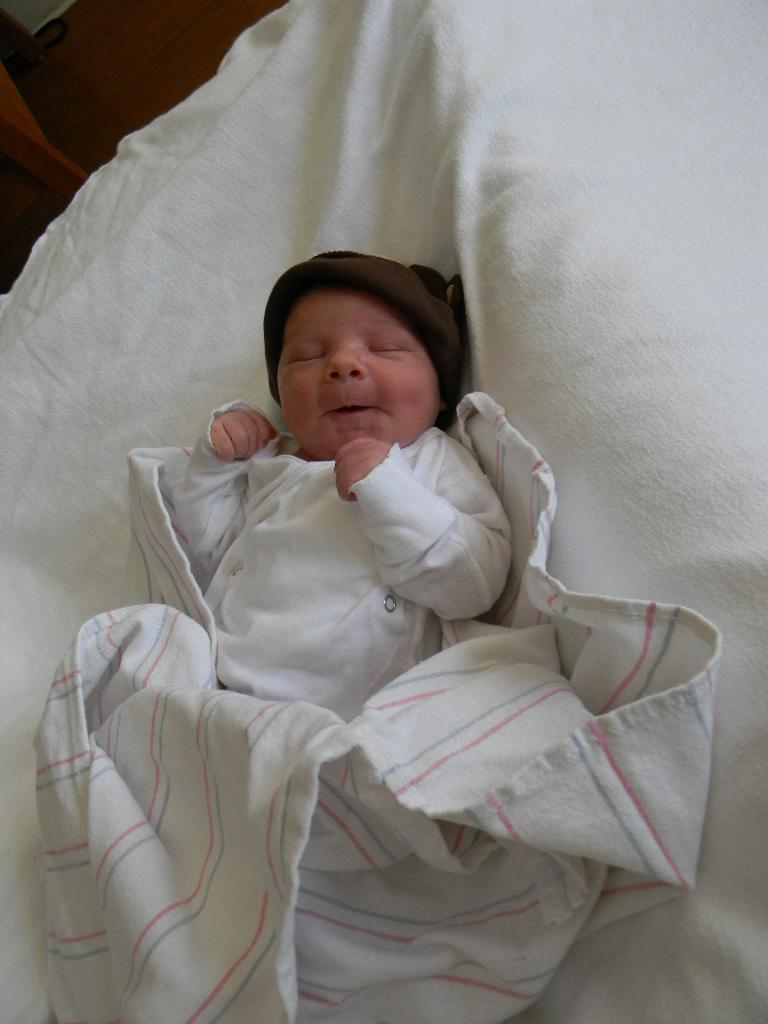What is the main subject of the picture? The main subject of the picture is a small baby. What is the baby wearing in the picture? The baby is wearing white clothes in the picture. Where is the baby located in the image? The baby is sleeping on a bed in the picture. Can you see any fangs on the baby in the picture? There are no fangs visible on the baby in the picture, as babies do not have fangs. What type of judgment is the baby making in the picture? The baby is sleeping in the picture and not making any judgments. 